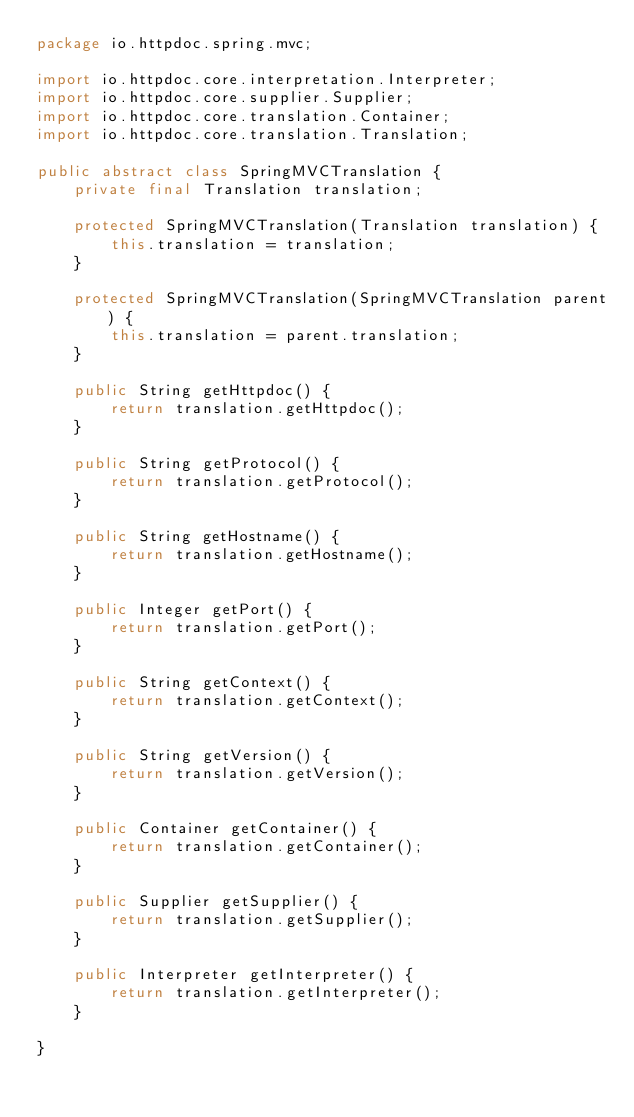<code> <loc_0><loc_0><loc_500><loc_500><_Java_>package io.httpdoc.spring.mvc;

import io.httpdoc.core.interpretation.Interpreter;
import io.httpdoc.core.supplier.Supplier;
import io.httpdoc.core.translation.Container;
import io.httpdoc.core.translation.Translation;

public abstract class SpringMVCTranslation {
    private final Translation translation;

    protected SpringMVCTranslation(Translation translation) {
        this.translation = translation;
    }

    protected SpringMVCTranslation(SpringMVCTranslation parent) {
        this.translation = parent.translation;
    }

    public String getHttpdoc() {
        return translation.getHttpdoc();
    }

    public String getProtocol() {
        return translation.getProtocol();
    }

    public String getHostname() {
        return translation.getHostname();
    }

    public Integer getPort() {
        return translation.getPort();
    }

    public String getContext() {
        return translation.getContext();
    }

    public String getVersion() {
        return translation.getVersion();
    }

    public Container getContainer() {
        return translation.getContainer();
    }

    public Supplier getSupplier() {
        return translation.getSupplier();
    }

    public Interpreter getInterpreter() {
        return translation.getInterpreter();
    }

}
</code> 